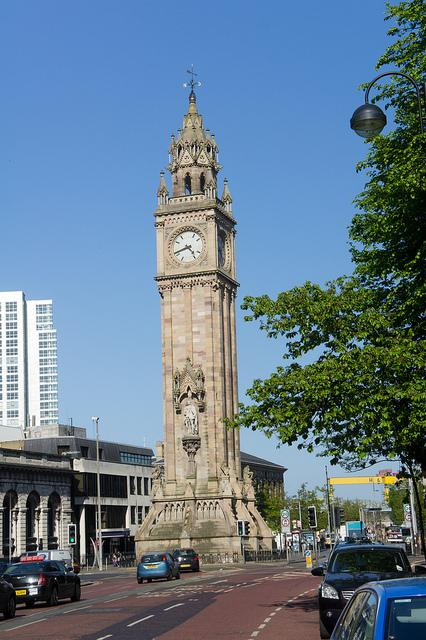What is near the tower? Please explain your reasoning. car. There are cars driving by. 